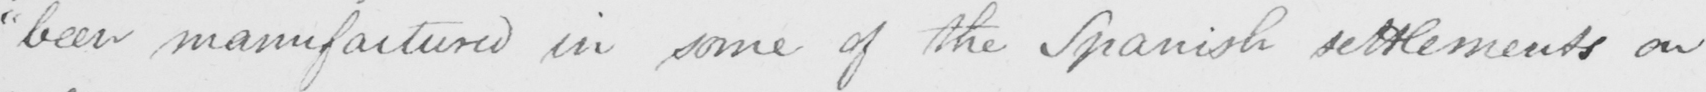What is written in this line of handwriting? " been manufactured in some of the Spanish settlements on 